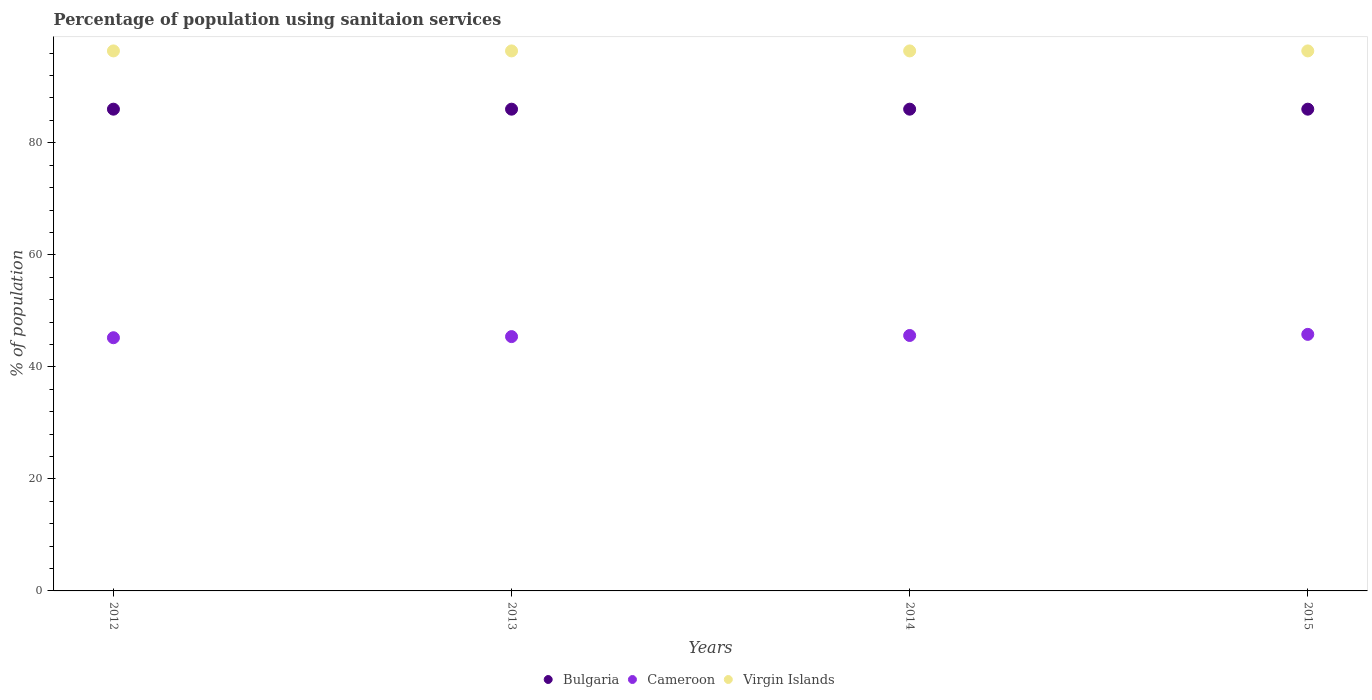How many different coloured dotlines are there?
Offer a terse response. 3. What is the percentage of population using sanitaion services in Cameroon in 2014?
Provide a short and direct response. 45.6. In which year was the percentage of population using sanitaion services in Cameroon maximum?
Provide a succinct answer. 2015. In which year was the percentage of population using sanitaion services in Virgin Islands minimum?
Give a very brief answer. 2012. What is the total percentage of population using sanitaion services in Virgin Islands in the graph?
Give a very brief answer. 385.6. What is the difference between the percentage of population using sanitaion services in Bulgaria in 2013 and that in 2014?
Make the answer very short. 0. What is the difference between the percentage of population using sanitaion services in Cameroon in 2015 and the percentage of population using sanitaion services in Bulgaria in 2014?
Your answer should be compact. -40.2. What is the average percentage of population using sanitaion services in Bulgaria per year?
Provide a short and direct response. 86. In the year 2012, what is the difference between the percentage of population using sanitaion services in Bulgaria and percentage of population using sanitaion services in Cameroon?
Your answer should be very brief. 40.8. In how many years, is the percentage of population using sanitaion services in Virgin Islands greater than 56 %?
Make the answer very short. 4. What is the ratio of the percentage of population using sanitaion services in Bulgaria in 2012 to that in 2015?
Provide a succinct answer. 1. Is the percentage of population using sanitaion services in Cameroon in 2012 less than that in 2013?
Provide a succinct answer. Yes. Is the sum of the percentage of population using sanitaion services in Bulgaria in 2014 and 2015 greater than the maximum percentage of population using sanitaion services in Virgin Islands across all years?
Ensure brevity in your answer.  Yes. Is the percentage of population using sanitaion services in Bulgaria strictly less than the percentage of population using sanitaion services in Cameroon over the years?
Give a very brief answer. No. How many dotlines are there?
Your answer should be very brief. 3. How many years are there in the graph?
Offer a terse response. 4. What is the difference between two consecutive major ticks on the Y-axis?
Make the answer very short. 20. Does the graph contain grids?
Ensure brevity in your answer.  No. How many legend labels are there?
Make the answer very short. 3. How are the legend labels stacked?
Offer a very short reply. Horizontal. What is the title of the graph?
Give a very brief answer. Percentage of population using sanitaion services. Does "Nigeria" appear as one of the legend labels in the graph?
Your answer should be compact. No. What is the label or title of the Y-axis?
Your response must be concise. % of population. What is the % of population in Bulgaria in 2012?
Give a very brief answer. 86. What is the % of population of Cameroon in 2012?
Your response must be concise. 45.2. What is the % of population of Virgin Islands in 2012?
Your response must be concise. 96.4. What is the % of population of Cameroon in 2013?
Give a very brief answer. 45.4. What is the % of population in Virgin Islands in 2013?
Your response must be concise. 96.4. What is the % of population in Cameroon in 2014?
Provide a succinct answer. 45.6. What is the % of population of Virgin Islands in 2014?
Provide a short and direct response. 96.4. What is the % of population in Bulgaria in 2015?
Your answer should be very brief. 86. What is the % of population in Cameroon in 2015?
Keep it short and to the point. 45.8. What is the % of population in Virgin Islands in 2015?
Your response must be concise. 96.4. Across all years, what is the maximum % of population in Bulgaria?
Provide a succinct answer. 86. Across all years, what is the maximum % of population in Cameroon?
Provide a short and direct response. 45.8. Across all years, what is the maximum % of population of Virgin Islands?
Ensure brevity in your answer.  96.4. Across all years, what is the minimum % of population in Bulgaria?
Your answer should be compact. 86. Across all years, what is the minimum % of population of Cameroon?
Provide a succinct answer. 45.2. Across all years, what is the minimum % of population of Virgin Islands?
Provide a short and direct response. 96.4. What is the total % of population in Bulgaria in the graph?
Make the answer very short. 344. What is the total % of population in Cameroon in the graph?
Offer a very short reply. 182. What is the total % of population in Virgin Islands in the graph?
Ensure brevity in your answer.  385.6. What is the difference between the % of population in Bulgaria in 2012 and that in 2013?
Your answer should be compact. 0. What is the difference between the % of population of Bulgaria in 2012 and that in 2014?
Your answer should be very brief. 0. What is the difference between the % of population in Cameroon in 2012 and that in 2014?
Offer a very short reply. -0.4. What is the difference between the % of population in Virgin Islands in 2012 and that in 2014?
Your answer should be very brief. 0. What is the difference between the % of population in Cameroon in 2012 and that in 2015?
Provide a short and direct response. -0.6. What is the difference between the % of population of Bulgaria in 2013 and that in 2014?
Offer a terse response. 0. What is the difference between the % of population of Virgin Islands in 2013 and that in 2014?
Provide a succinct answer. 0. What is the difference between the % of population of Bulgaria in 2013 and that in 2015?
Your response must be concise. 0. What is the difference between the % of population in Cameroon in 2013 and that in 2015?
Ensure brevity in your answer.  -0.4. What is the difference between the % of population of Bulgaria in 2012 and the % of population of Cameroon in 2013?
Your answer should be compact. 40.6. What is the difference between the % of population of Bulgaria in 2012 and the % of population of Virgin Islands in 2013?
Offer a very short reply. -10.4. What is the difference between the % of population of Cameroon in 2012 and the % of population of Virgin Islands in 2013?
Make the answer very short. -51.2. What is the difference between the % of population of Bulgaria in 2012 and the % of population of Cameroon in 2014?
Provide a short and direct response. 40.4. What is the difference between the % of population in Cameroon in 2012 and the % of population in Virgin Islands in 2014?
Offer a terse response. -51.2. What is the difference between the % of population of Bulgaria in 2012 and the % of population of Cameroon in 2015?
Your answer should be very brief. 40.2. What is the difference between the % of population in Bulgaria in 2012 and the % of population in Virgin Islands in 2015?
Your answer should be compact. -10.4. What is the difference between the % of population in Cameroon in 2012 and the % of population in Virgin Islands in 2015?
Your response must be concise. -51.2. What is the difference between the % of population of Bulgaria in 2013 and the % of population of Cameroon in 2014?
Provide a short and direct response. 40.4. What is the difference between the % of population of Cameroon in 2013 and the % of population of Virgin Islands in 2014?
Provide a short and direct response. -51. What is the difference between the % of population in Bulgaria in 2013 and the % of population in Cameroon in 2015?
Ensure brevity in your answer.  40.2. What is the difference between the % of population of Cameroon in 2013 and the % of population of Virgin Islands in 2015?
Give a very brief answer. -51. What is the difference between the % of population in Bulgaria in 2014 and the % of population in Cameroon in 2015?
Offer a very short reply. 40.2. What is the difference between the % of population of Bulgaria in 2014 and the % of population of Virgin Islands in 2015?
Your response must be concise. -10.4. What is the difference between the % of population in Cameroon in 2014 and the % of population in Virgin Islands in 2015?
Provide a succinct answer. -50.8. What is the average % of population in Cameroon per year?
Provide a short and direct response. 45.5. What is the average % of population in Virgin Islands per year?
Make the answer very short. 96.4. In the year 2012, what is the difference between the % of population of Bulgaria and % of population of Cameroon?
Your answer should be very brief. 40.8. In the year 2012, what is the difference between the % of population of Bulgaria and % of population of Virgin Islands?
Keep it short and to the point. -10.4. In the year 2012, what is the difference between the % of population in Cameroon and % of population in Virgin Islands?
Ensure brevity in your answer.  -51.2. In the year 2013, what is the difference between the % of population in Bulgaria and % of population in Cameroon?
Ensure brevity in your answer.  40.6. In the year 2013, what is the difference between the % of population in Bulgaria and % of population in Virgin Islands?
Your answer should be very brief. -10.4. In the year 2013, what is the difference between the % of population of Cameroon and % of population of Virgin Islands?
Keep it short and to the point. -51. In the year 2014, what is the difference between the % of population in Bulgaria and % of population in Cameroon?
Your answer should be compact. 40.4. In the year 2014, what is the difference between the % of population of Bulgaria and % of population of Virgin Islands?
Offer a terse response. -10.4. In the year 2014, what is the difference between the % of population of Cameroon and % of population of Virgin Islands?
Your answer should be compact. -50.8. In the year 2015, what is the difference between the % of population in Bulgaria and % of population in Cameroon?
Offer a terse response. 40.2. In the year 2015, what is the difference between the % of population in Bulgaria and % of population in Virgin Islands?
Offer a very short reply. -10.4. In the year 2015, what is the difference between the % of population of Cameroon and % of population of Virgin Islands?
Your answer should be compact. -50.6. What is the ratio of the % of population of Bulgaria in 2012 to that in 2014?
Ensure brevity in your answer.  1. What is the ratio of the % of population in Cameroon in 2012 to that in 2014?
Give a very brief answer. 0.99. What is the ratio of the % of population of Virgin Islands in 2012 to that in 2014?
Provide a short and direct response. 1. What is the ratio of the % of population of Bulgaria in 2012 to that in 2015?
Make the answer very short. 1. What is the ratio of the % of population in Cameroon in 2012 to that in 2015?
Offer a very short reply. 0.99. What is the ratio of the % of population of Bulgaria in 2013 to that in 2014?
Provide a short and direct response. 1. What is the ratio of the % of population of Cameroon in 2013 to that in 2015?
Provide a succinct answer. 0.99. What is the ratio of the % of population of Virgin Islands in 2014 to that in 2015?
Offer a terse response. 1. What is the difference between the highest and the second highest % of population of Bulgaria?
Your answer should be compact. 0. What is the difference between the highest and the lowest % of population of Bulgaria?
Your response must be concise. 0. 